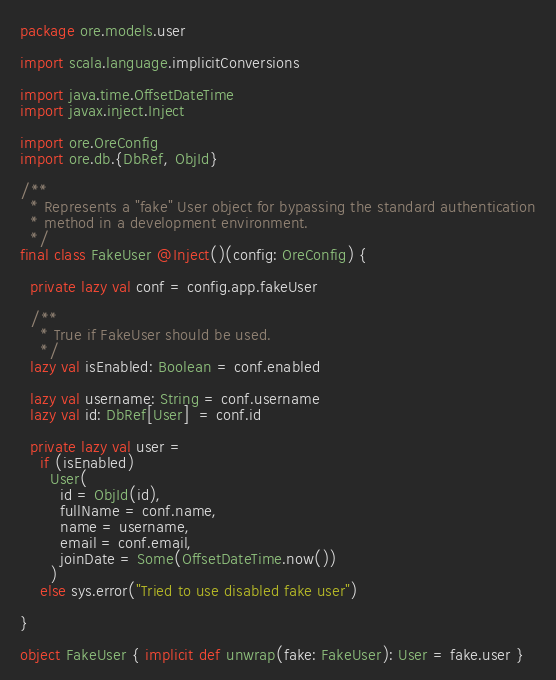<code> <loc_0><loc_0><loc_500><loc_500><_Scala_>package ore.models.user

import scala.language.implicitConversions

import java.time.OffsetDateTime
import javax.inject.Inject

import ore.OreConfig
import ore.db.{DbRef, ObjId}

/**
  * Represents a "fake" User object for bypassing the standard authentication
  * method in a development environment.
  */
final class FakeUser @Inject()(config: OreConfig) {

  private lazy val conf = config.app.fakeUser

  /**
    * True if FakeUser should be used.
    */
  lazy val isEnabled: Boolean = conf.enabled

  lazy val username: String = conf.username
  lazy val id: DbRef[User]  = conf.id

  private lazy val user =
    if (isEnabled)
      User(
        id = ObjId(id),
        fullName = conf.name,
        name = username,
        email = conf.email,
        joinDate = Some(OffsetDateTime.now())
      )
    else sys.error("Tried to use disabled fake user")

}

object FakeUser { implicit def unwrap(fake: FakeUser): User = fake.user }
</code> 